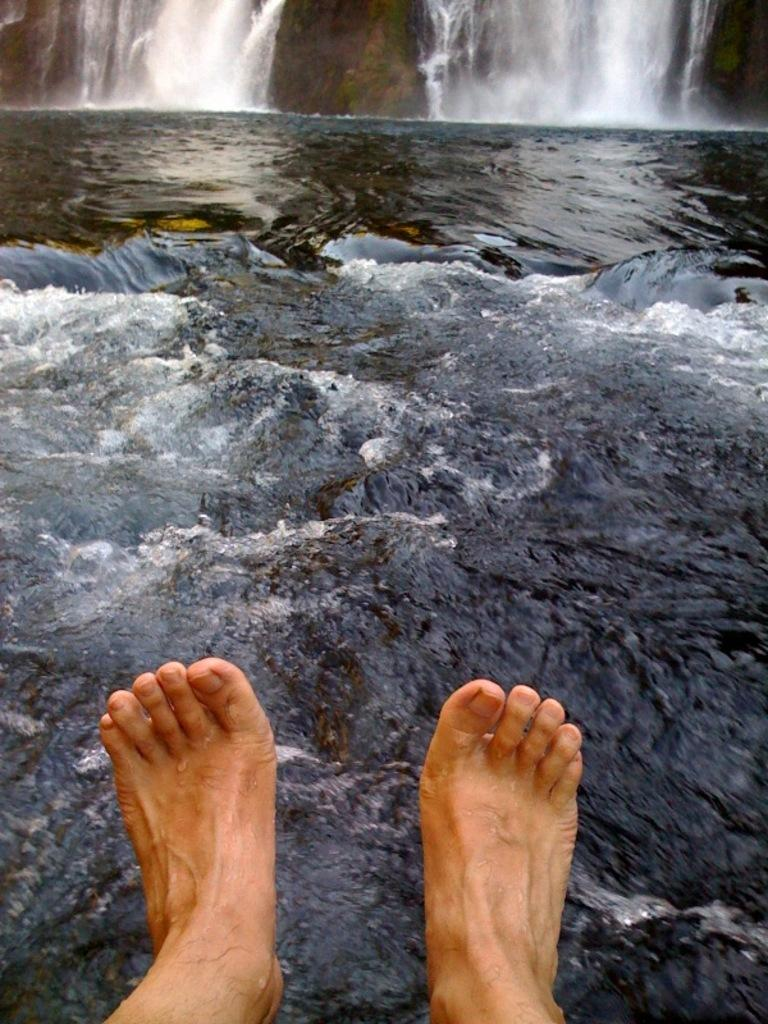What is visible in the foreground of the image? There are feet of a person in the foreground of the image. What natural element can be seen in the image? There is water visible in the image. What type of water feature is present at the top of the image? There is a waterfall at the top of the image. What type of cheese is being used to comfort the person in the image? There is no cheese or indication of comfort in the image; it features a person's feet and a waterfall. 